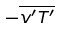<formula> <loc_0><loc_0><loc_500><loc_500>- \overline { v ^ { \prime } T ^ { \prime } }</formula> 